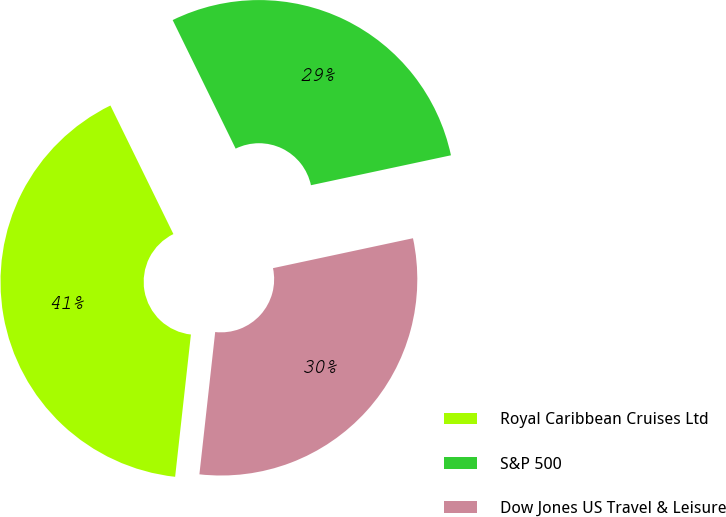Convert chart. <chart><loc_0><loc_0><loc_500><loc_500><pie_chart><fcel>Royal Caribbean Cruises Ltd<fcel>S&P 500<fcel>Dow Jones US Travel & Leisure<nl><fcel>40.99%<fcel>28.9%<fcel>30.11%<nl></chart> 